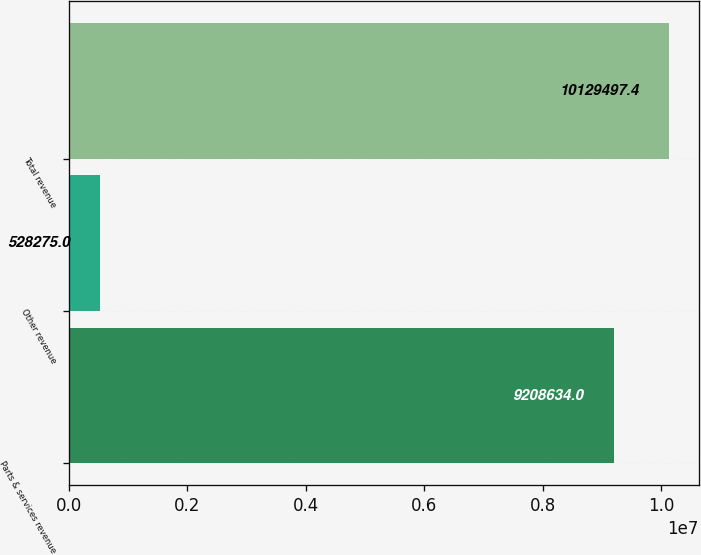Convert chart to OTSL. <chart><loc_0><loc_0><loc_500><loc_500><bar_chart><fcel>Parts & services revenue<fcel>Other revenue<fcel>Total revenue<nl><fcel>9.20863e+06<fcel>528275<fcel>1.01295e+07<nl></chart> 